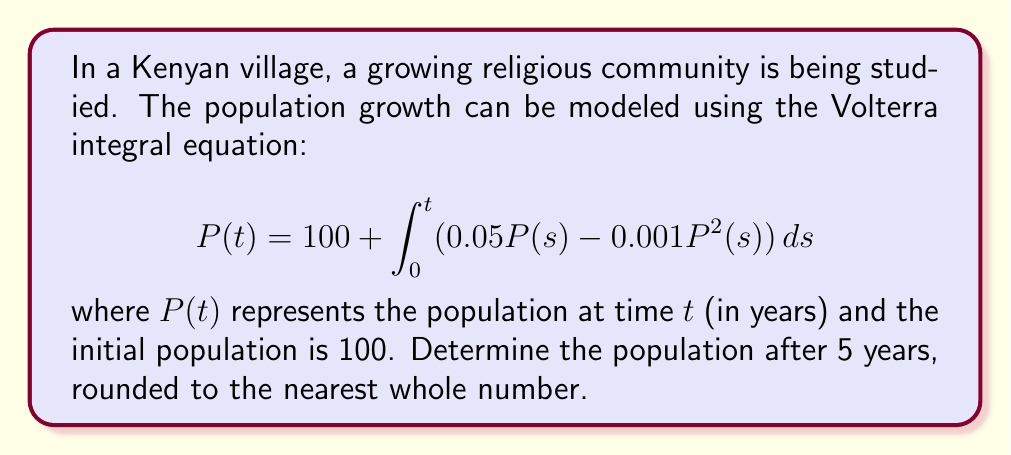Can you answer this question? To solve this Volterra integral equation, we'll use numerical methods, specifically the Euler method, as an exact analytical solution is difficult to obtain.

Step 1: Rewrite the equation as a differential equation
$$\frac{dP}{dt} = 0.05P - 0.001P^2$$

Step 2: Set up the Euler method
Choose a small time step, let's use $\Delta t = 0.1$ years.
The Euler method formula is:
$$P(t + \Delta t) = P(t) + \Delta t \cdot (0.05P(t) - 0.001P^2(t))$$

Step 3: Implement the Euler method
Starting with $P(0) = 100$, we'll iterate 50 times to reach 5 years:

$P(0.1) = 100 + 0.1 \cdot (0.05 \cdot 100 - 0.001 \cdot 100^2) = 100.4$
$P(0.2) = 100.4 + 0.1 \cdot (0.05 \cdot 100.4 - 0.001 \cdot 100.4^2) = 100.8016$
...

Continue this process for 50 iterations.

Step 4: Final calculation
After 50 iterations, we get:
$P(5) \approx 131.6791$

Step 5: Round to the nearest whole number
$132$
Answer: 132 